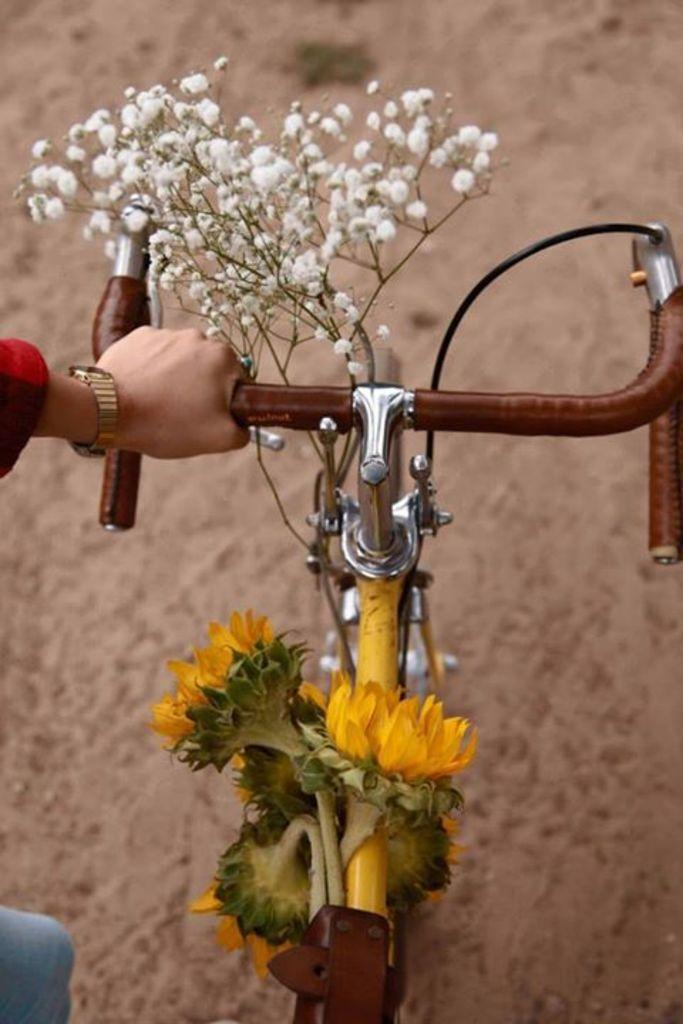What is the main subject of the image? There is a person in the image. What is the person holding in the image? The person is holding the handle of a bicycle. Can you describe the bicycle in the image? The bicycle is decorated with flowers. What type of trouble is the cook experiencing in the image? There is no cook or trouble present in the image; it features a person holding the handle of a bicycle that is decorated with flowers. 